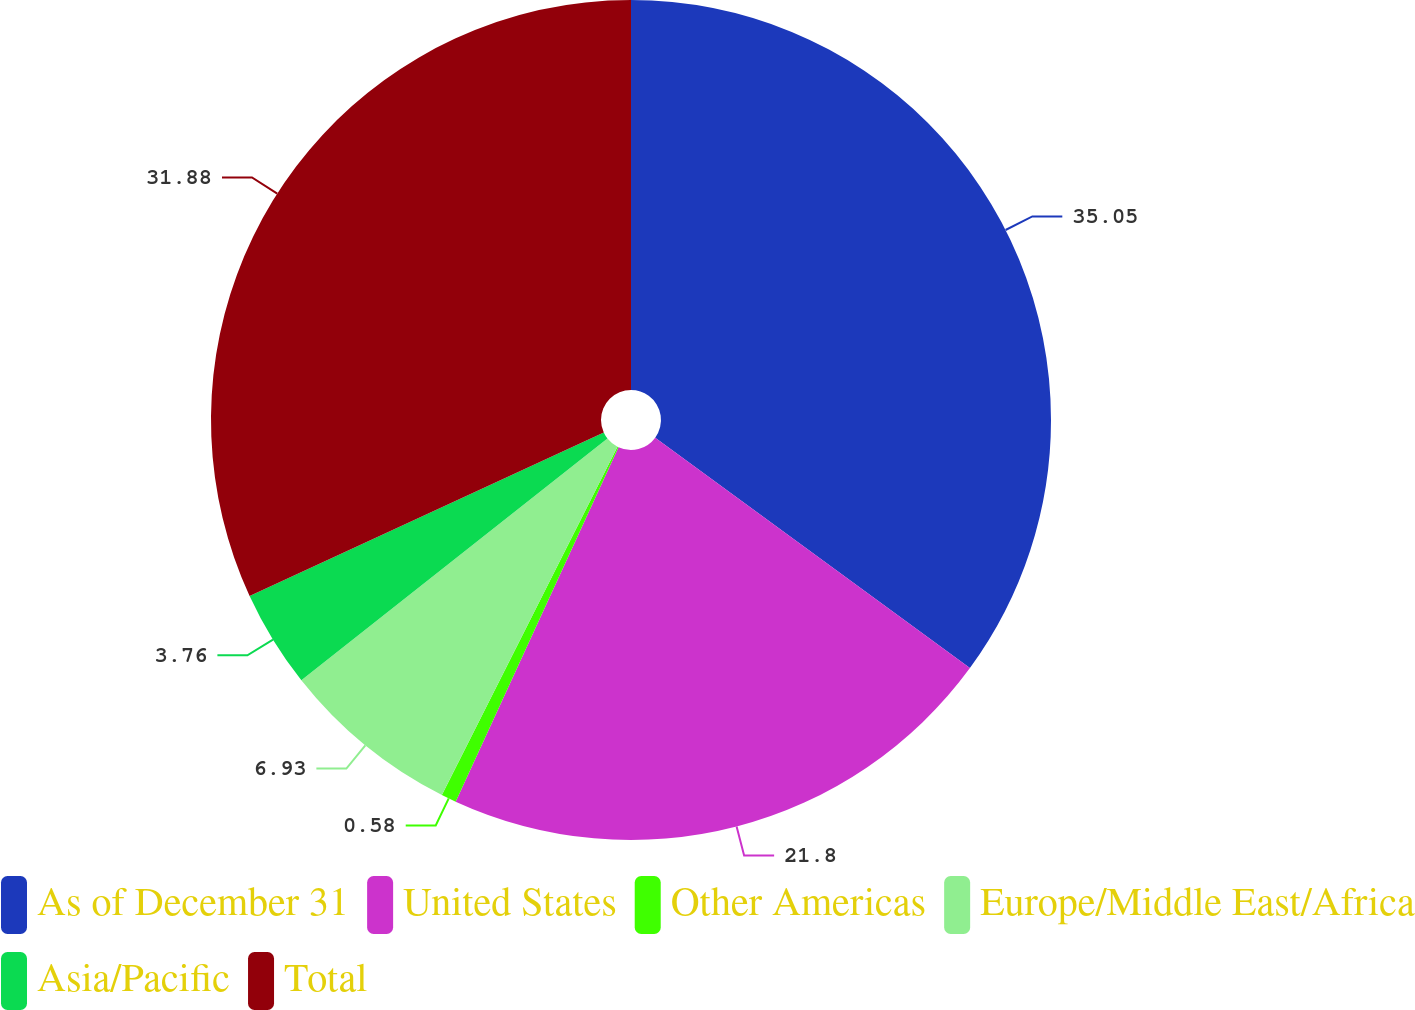<chart> <loc_0><loc_0><loc_500><loc_500><pie_chart><fcel>As of December 31<fcel>United States<fcel>Other Americas<fcel>Europe/Middle East/Africa<fcel>Asia/Pacific<fcel>Total<nl><fcel>35.06%<fcel>21.8%<fcel>0.58%<fcel>6.93%<fcel>3.76%<fcel>31.88%<nl></chart> 